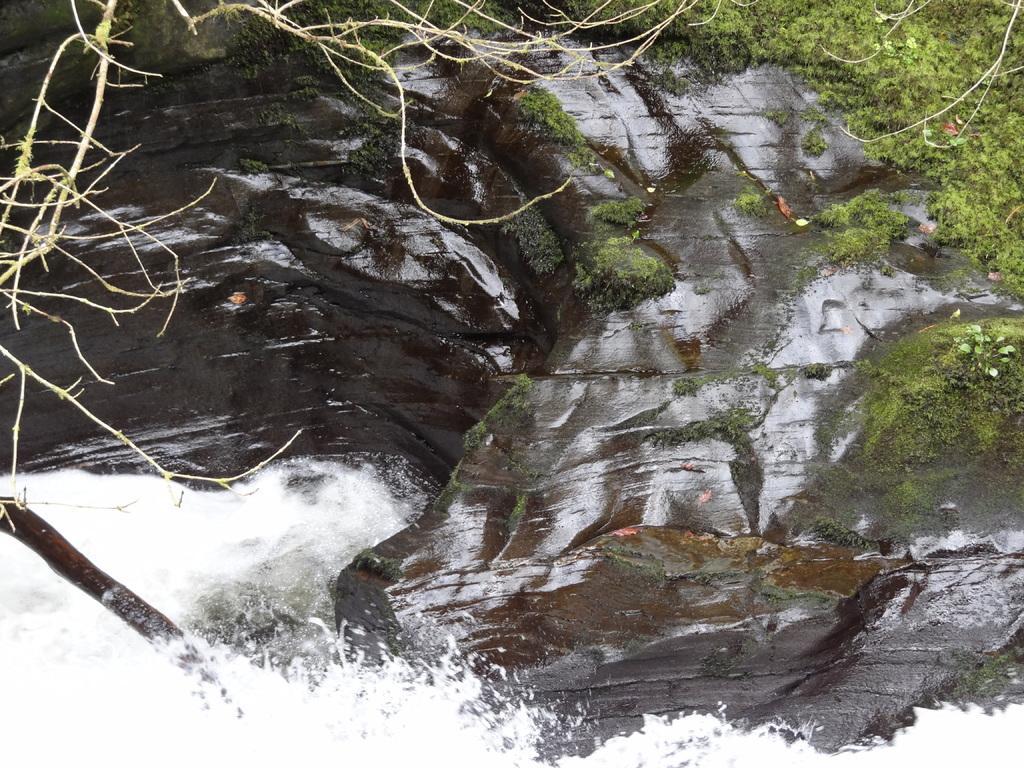Describe this image in one or two sentences. There is water flowing on the rock. There is grass on the rock. Also we can see some branches. 